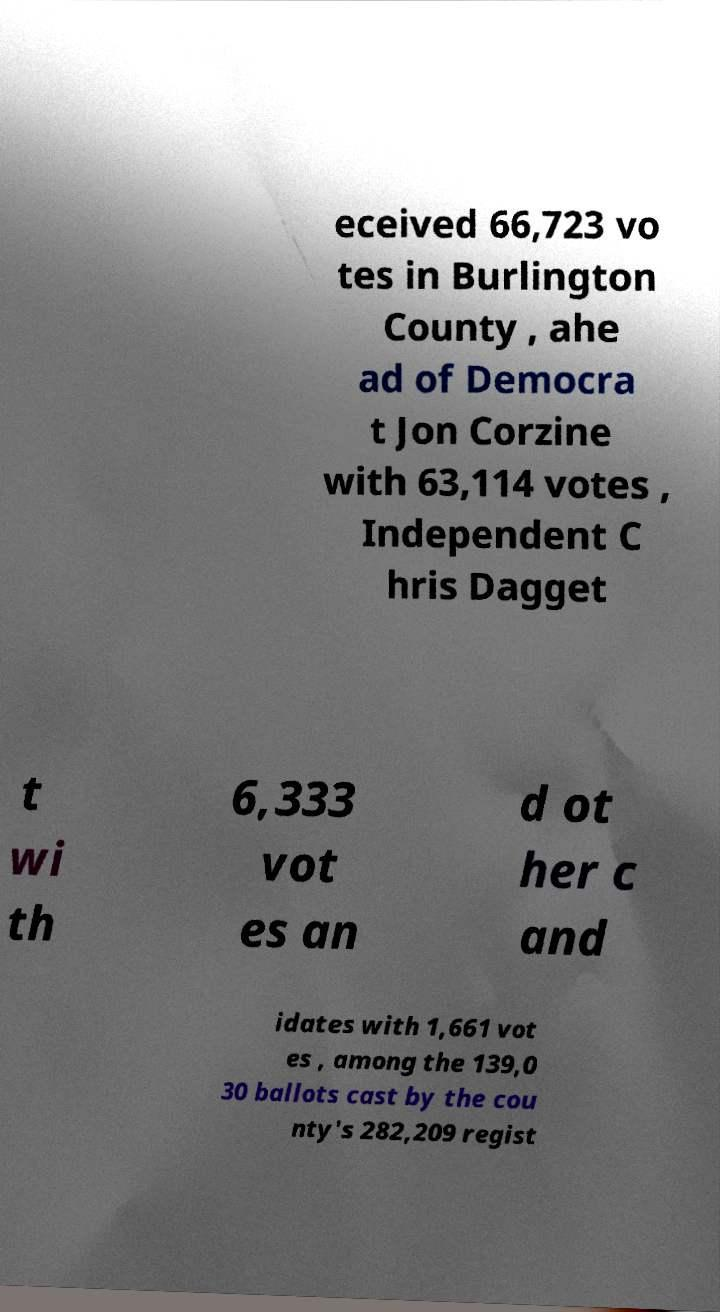There's text embedded in this image that I need extracted. Can you transcribe it verbatim? eceived 66,723 vo tes in Burlington County , ahe ad of Democra t Jon Corzine with 63,114 votes , Independent C hris Dagget t wi th 6,333 vot es an d ot her c and idates with 1,661 vot es , among the 139,0 30 ballots cast by the cou nty's 282,209 regist 